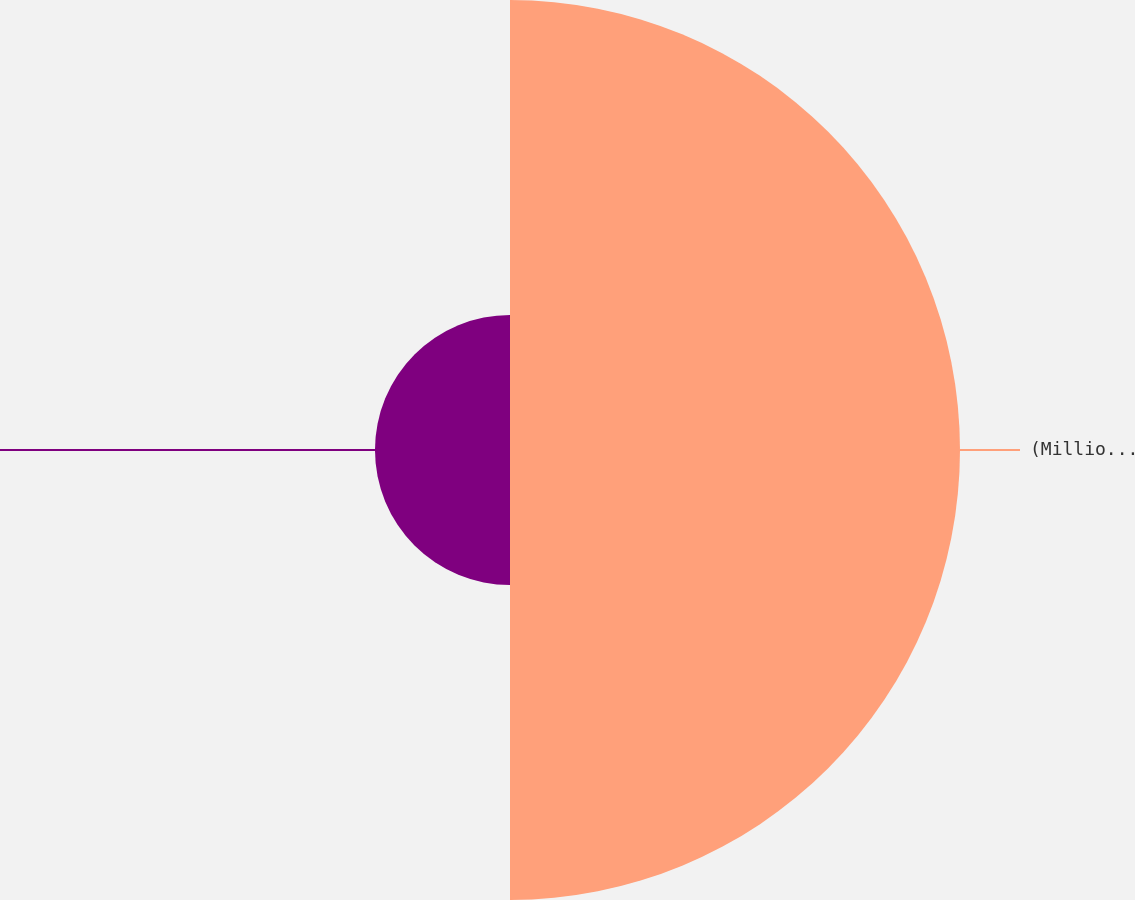Convert chart to OTSL. <chart><loc_0><loc_0><loc_500><loc_500><pie_chart><fcel>(MillionsofDollars)<fcel>Unnamed: 1<nl><fcel>76.92%<fcel>23.08%<nl></chart> 